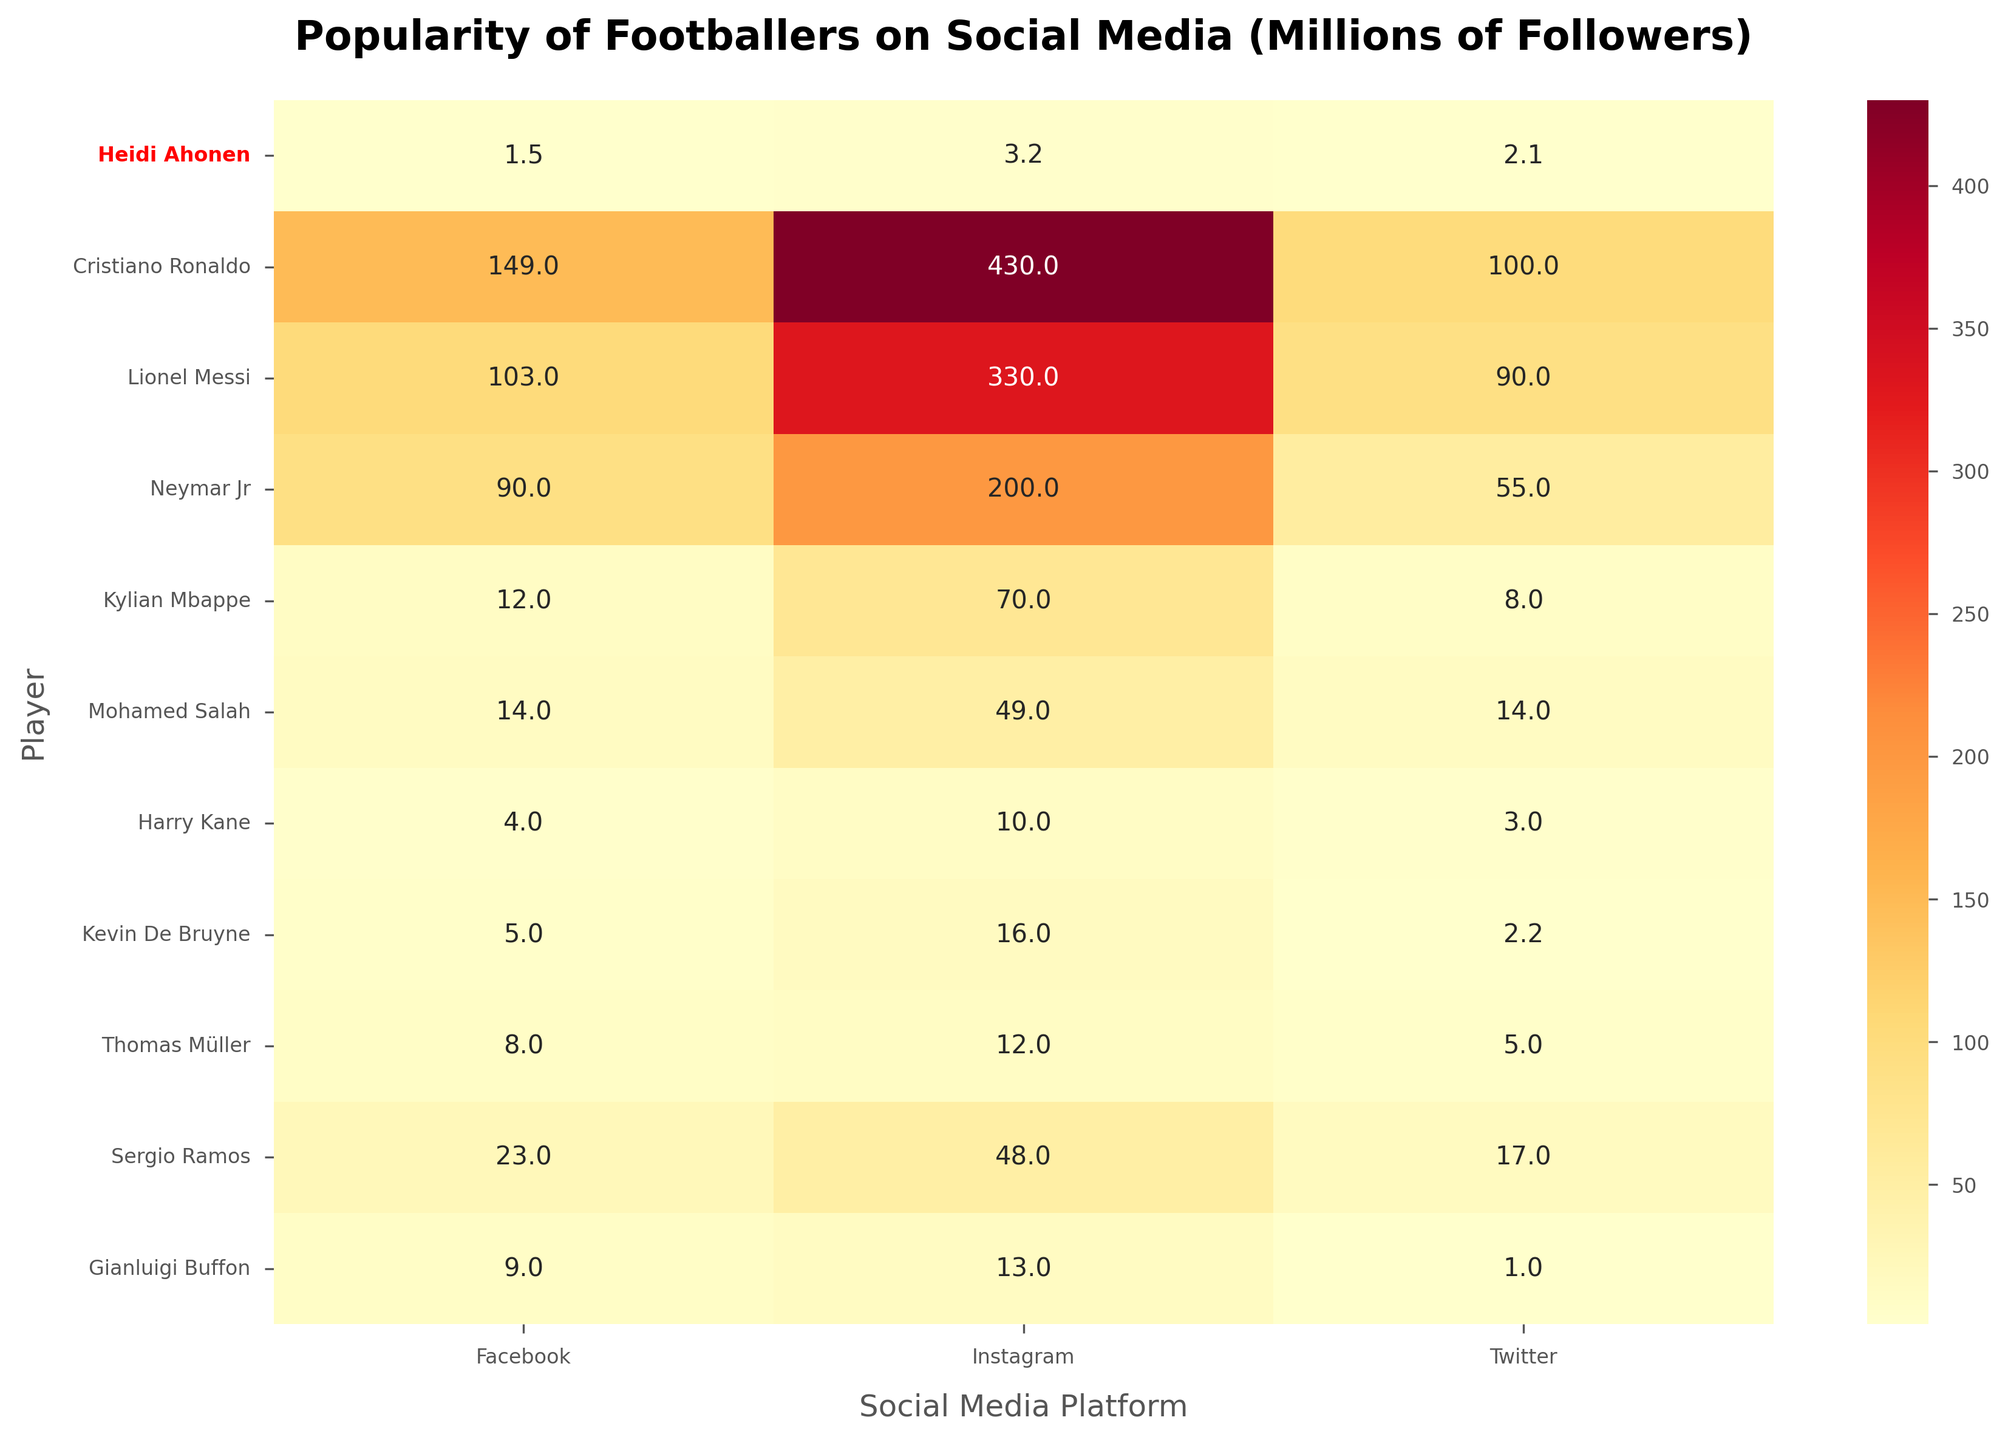Which player has the most Instagram followers? The title and annotations show that Cristiano Ronaldo has the highest Instagram followers with 430 million.
Answer: Cristiano Ronaldo How many Facebook followers does Lionel Messi have? By looking at the first column under Facebook Followers, Lionel Messi has 103 million followers.
Answer: 103 million What is the total number of Twitter followers for Neymar Jr? The data under the Twitter Followers column indicates that Neymar Jr has 55 million followers.
Answer: 55 million Who has more Twitter followers, Heidi Ahonen or Kevin De Bruyne? Comparing the Twitter followers of Heidi Ahonen (2.1 million) and Kevin De Bruyne (2.2 million), Kevin De Bruyne has more followers.
Answer: Kevin De Bruyne What is the average number of followers for Facebook, Instagram, and Twitter combined for Mohamed Salah? Adding up Mohamed Salah's followers (14 million on Facebook, 49 million on Instagram, 14 million on Twitter) gives a total of 77 million. The average is 77/3 = 25.67 million.
Answer: 25.67 million Compare the Instagram followers of Harry Kane and Gianluigi Buffon. Who has more? Comparing the Instagram followers of Harry Kane (10 million) and Gianluigi Buffon (13 million), Gianluigi Buffon has more.
Answer: Gianluigi Buffon Which platform does Heidi Ahonen have the least followers on? Based on the values for Heidi Ahonen, she has the least followers on Facebook with 1.5 million.
Answer: Facebook Rank the players by their total social media presence (sum of Facebook, Instagram, and Twitter followers) from highest to lowest. Sum the followers for each player and rank accordingly. Cristiano Ronaldo (679M), Lionel Messi (523M), Neymar Jr (345M), Kylian Mbappe (90M), Mohamed Salah (77M), Sergio Ramos (88M), Thomas Müller (25M), Gianluigi Buffon (23M), Harry Kane (17M), Kevin De Bruyne (23.2M).
Answer: Cristiano Ronaldo, Lionel Messi, Neymar Jr, Kylian Mbappe, Mohamed Salah, Sergio Ramos, Thomas Müller, Gianluigi Buffon, Kevin De Bruyne, Harry Kane What is the difference in Instagram followers between Cristiano Ronaldo and Lionel Messi? Subtract Lionel Messi's Instagram followers (330 million) from Cristiano Ronaldo's followers (430 million), which equals 100 million.
Answer: 100 million Which player has the most balanced distribution of followers across all three platforms? Assess each player's data to find who has the least variation between their social media follower counts. Heidi Ahonen has 1.5M on Facebook, 3.2M on Instagram, and 2.1M on Twitter, which shows relatively balanced counts compared to other players.
Answer: Heidi Ahonen 